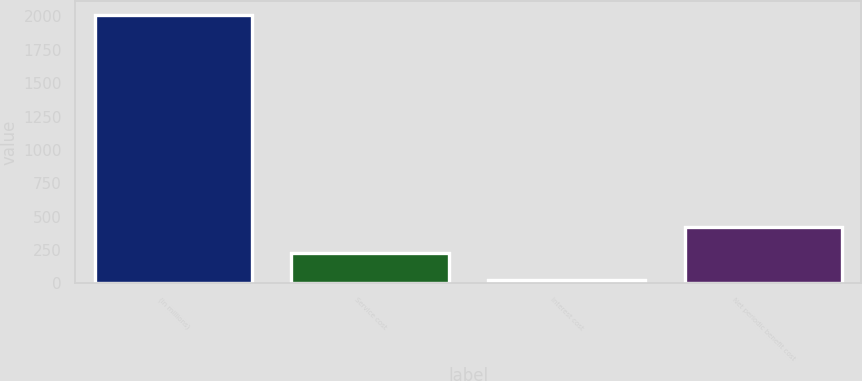<chart> <loc_0><loc_0><loc_500><loc_500><bar_chart><fcel>(in millions)<fcel>Service cost<fcel>Interest cost<fcel>Net periodic benefit cost<nl><fcel>2013<fcel>227.4<fcel>29<fcel>425.8<nl></chart> 